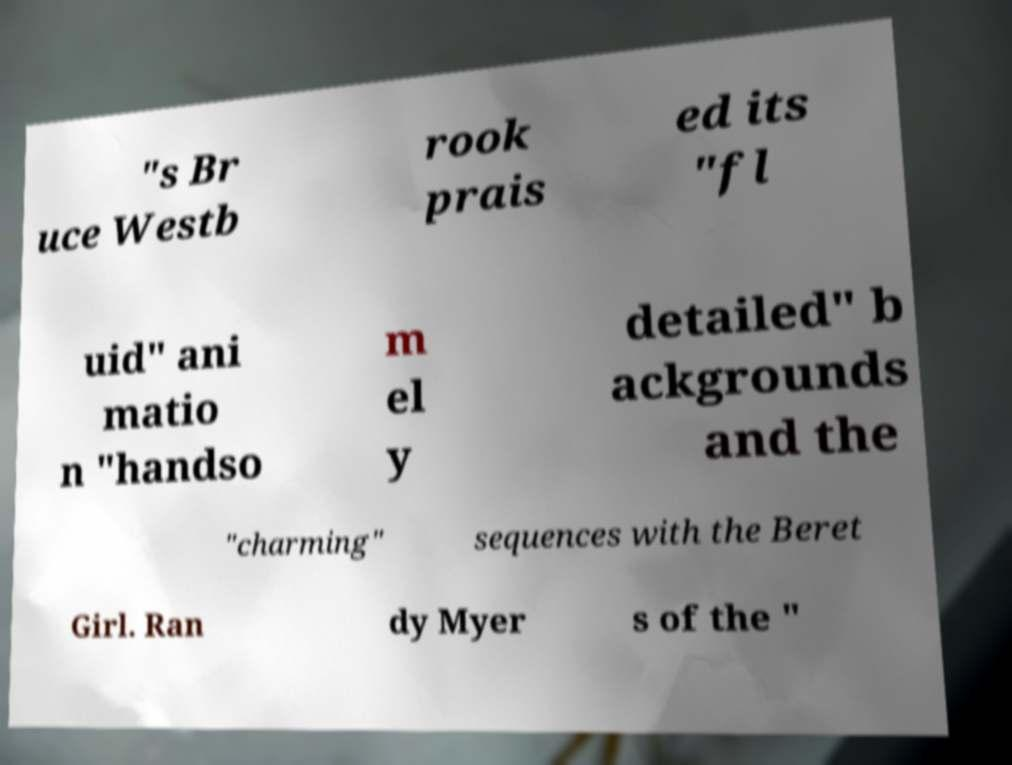I need the written content from this picture converted into text. Can you do that? "s Br uce Westb rook prais ed its "fl uid" ani matio n "handso m el y detailed" b ackgrounds and the "charming" sequences with the Beret Girl. Ran dy Myer s of the " 